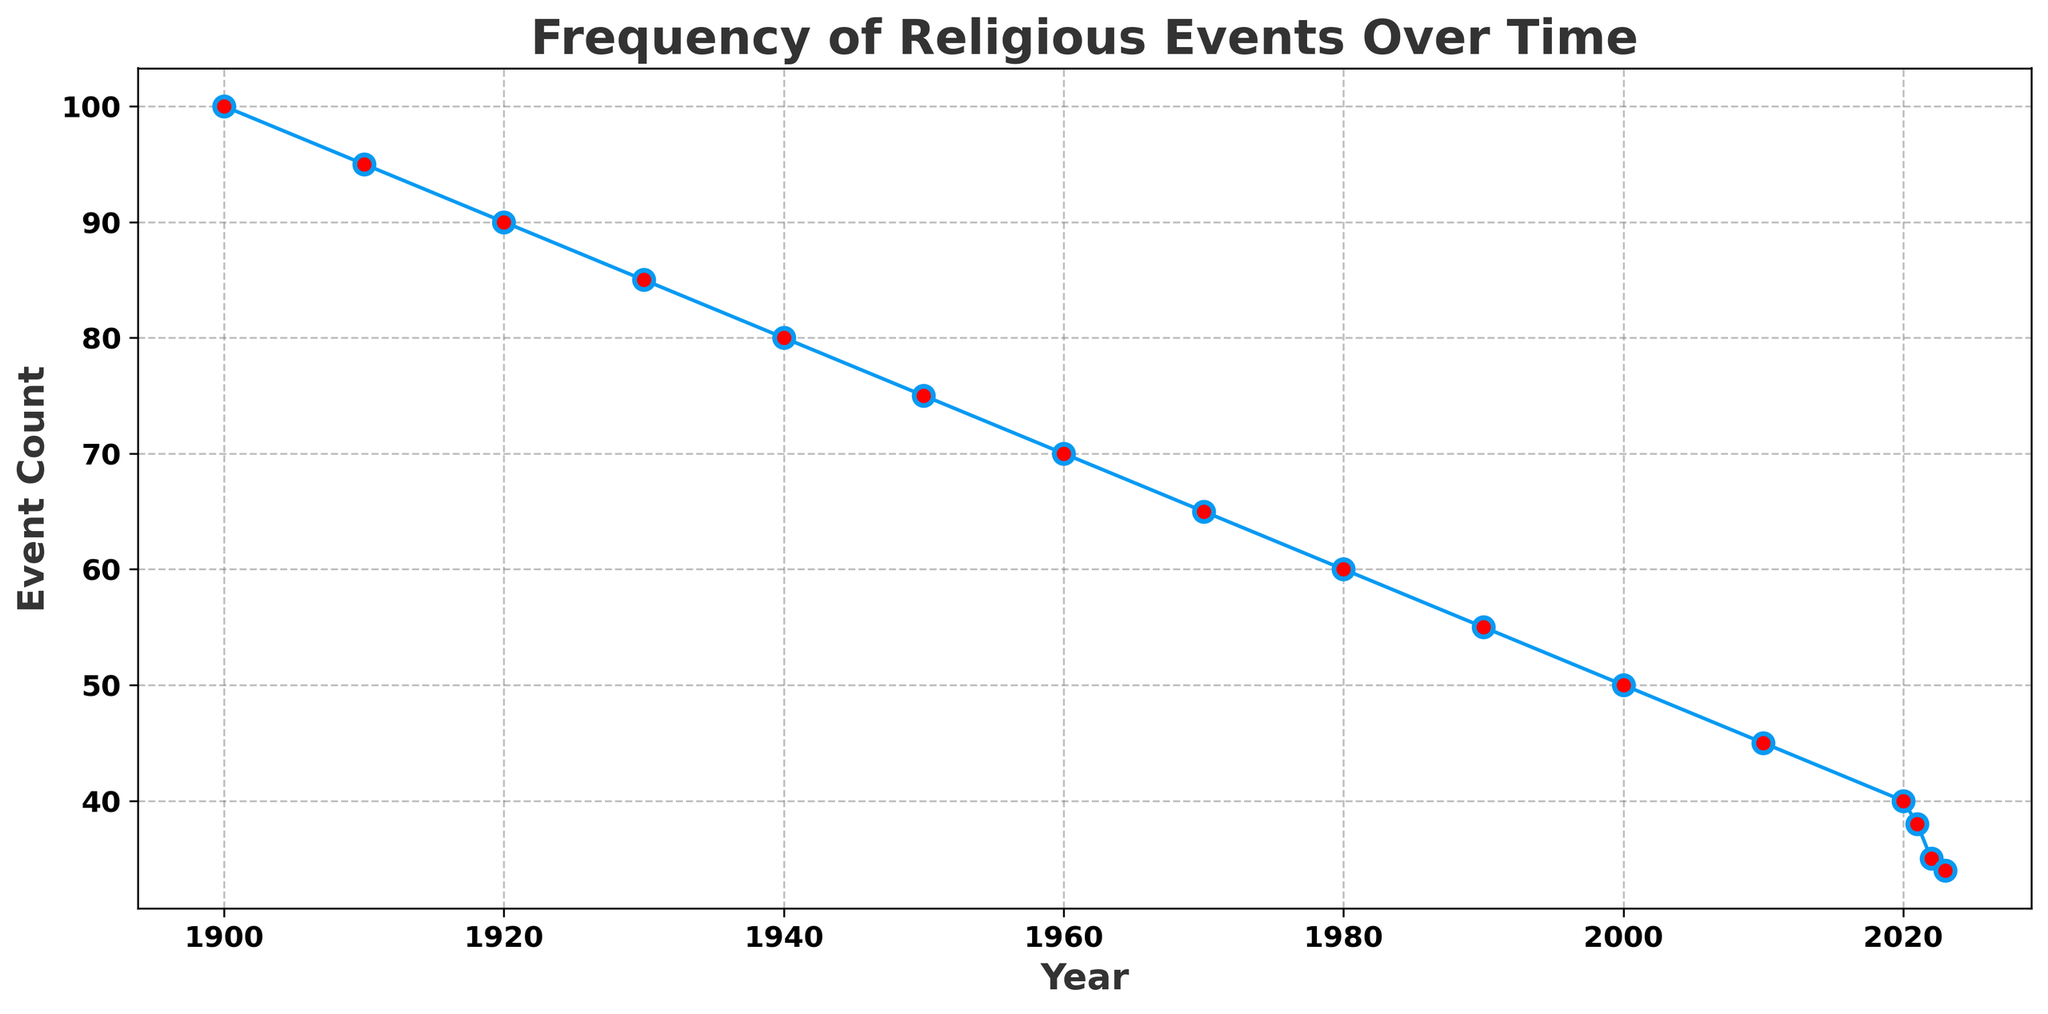When did the largest number of religious events occur? To identify the year with the highest event count, observe the plot to determine which year corresponds to the maximum point on the y-axis, which represents event counts.
Answer: 1900 Which year saw a greater decline in event count, from 1940 to 1950 or from 2000 to 2010? Calculate the decline in event count between both periods. For 1940-1950, it's 80 - 75 = 5. For 2000-2010, it's 50 - 45 = 5. So the declines are equal for both periods.
Answer: Equal In which decade did the frequency of religious events decline the most? To find this, observe the decrease in event counts for each decade and identify the decade with the largest difference between the starting and ending event counts.
Answer: 1900-1910 How many religious events occurred in total from 2000 to 2023? Sum the event counts from the years 2000, 2010, 2020, 2021, 2022, and 2023. 50 + 45 + 40 + 38 + 35 + 34 = 242.
Answer: 242 By how much did the event count decrease from 1910 to 2020? Subtract the event count of 2020 from that of 1910. 95 (in 1910) - 40 (in 2020) = 55.
Answer: 55 Which year has fewer event counts, 1980 or 2000? Compare the event counts of 1980 and 2000. The event count in 1980 is 60 and in 2000 is 50. Since 50 is less than 60, 2000 has fewer event counts.
Answer: 2000 What is the average event count for the years 1910, 1920, and 1930? Calculate the average by summing the event counts for 1910, 1920, and 1930, then divide by the number of years. (95 + 90 + 85) / 3 = 270 / 3 = 90
Answer: 90 Which year had the lowest event count within the plotted data? Look for the year corresponding to the lowest point on the plot which represents the event counts. The lowest count is 34 in 2023.
Answer: 2023 